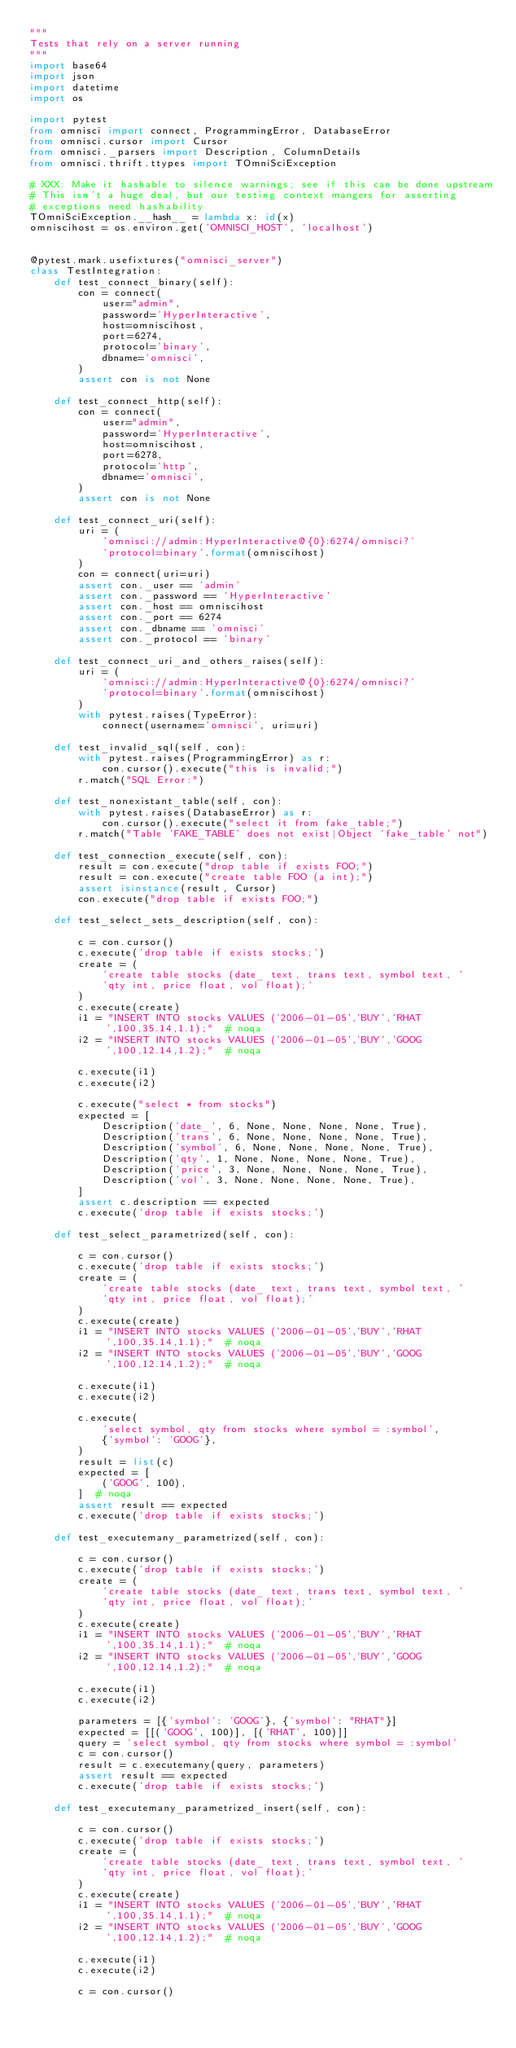Convert code to text. <code><loc_0><loc_0><loc_500><loc_500><_Python_>"""
Tests that rely on a server running
"""
import base64
import json
import datetime
import os

import pytest
from omnisci import connect, ProgrammingError, DatabaseError
from omnisci.cursor import Cursor
from omnisci._parsers import Description, ColumnDetails
from omnisci.thrift.ttypes import TOmniSciException

# XXX: Make it hashable to silence warnings; see if this can be done upstream
# This isn't a huge deal, but our testing context mangers for asserting
# exceptions need hashability
TOmniSciException.__hash__ = lambda x: id(x)
omniscihost = os.environ.get('OMNISCI_HOST', 'localhost')


@pytest.mark.usefixtures("omnisci_server")
class TestIntegration:
    def test_connect_binary(self):
        con = connect(
            user="admin",
            password='HyperInteractive',
            host=omniscihost,
            port=6274,
            protocol='binary',
            dbname='omnisci',
        )
        assert con is not None

    def test_connect_http(self):
        con = connect(
            user="admin",
            password='HyperInteractive',
            host=omniscihost,
            port=6278,
            protocol='http',
            dbname='omnisci',
        )
        assert con is not None

    def test_connect_uri(self):
        uri = (
            'omnisci://admin:HyperInteractive@{0}:6274/omnisci?'
            'protocol=binary'.format(omniscihost)
        )
        con = connect(uri=uri)
        assert con._user == 'admin'
        assert con._password == 'HyperInteractive'
        assert con._host == omniscihost
        assert con._port == 6274
        assert con._dbname == 'omnisci'
        assert con._protocol == 'binary'

    def test_connect_uri_and_others_raises(self):
        uri = (
            'omnisci://admin:HyperInteractive@{0}:6274/omnisci?'
            'protocol=binary'.format(omniscihost)
        )
        with pytest.raises(TypeError):
            connect(username='omnisci', uri=uri)

    def test_invalid_sql(self, con):
        with pytest.raises(ProgrammingError) as r:
            con.cursor().execute("this is invalid;")
        r.match("SQL Error:")

    def test_nonexistant_table(self, con):
        with pytest.raises(DatabaseError) as r:
            con.cursor().execute("select it from fake_table;")
        r.match("Table 'FAKE_TABLE' does not exist|Object 'fake_table' not")

    def test_connection_execute(self, con):
        result = con.execute("drop table if exists FOO;")
        result = con.execute("create table FOO (a int);")
        assert isinstance(result, Cursor)
        con.execute("drop table if exists FOO;")

    def test_select_sets_description(self, con):

        c = con.cursor()
        c.execute('drop table if exists stocks;')
        create = (
            'create table stocks (date_ text, trans text, symbol text, '
            'qty int, price float, vol float);'
        )
        c.execute(create)
        i1 = "INSERT INTO stocks VALUES ('2006-01-05','BUY','RHAT',100,35.14,1.1);"  # noqa
        i2 = "INSERT INTO stocks VALUES ('2006-01-05','BUY','GOOG',100,12.14,1.2);"  # noqa

        c.execute(i1)
        c.execute(i2)

        c.execute("select * from stocks")
        expected = [
            Description('date_', 6, None, None, None, None, True),
            Description('trans', 6, None, None, None, None, True),
            Description('symbol', 6, None, None, None, None, True),
            Description('qty', 1, None, None, None, None, True),
            Description('price', 3, None, None, None, None, True),
            Description('vol', 3, None, None, None, None, True),
        ]
        assert c.description == expected
        c.execute('drop table if exists stocks;')

    def test_select_parametrized(self, con):

        c = con.cursor()
        c.execute('drop table if exists stocks;')
        create = (
            'create table stocks (date_ text, trans text, symbol text, '
            'qty int, price float, vol float);'
        )
        c.execute(create)
        i1 = "INSERT INTO stocks VALUES ('2006-01-05','BUY','RHAT',100,35.14,1.1);"  # noqa
        i2 = "INSERT INTO stocks VALUES ('2006-01-05','BUY','GOOG',100,12.14,1.2);"  # noqa

        c.execute(i1)
        c.execute(i2)

        c.execute(
            'select symbol, qty from stocks where symbol = :symbol',
            {'symbol': 'GOOG'},
        )
        result = list(c)
        expected = [
            ('GOOG', 100),
        ]  # noqa
        assert result == expected
        c.execute('drop table if exists stocks;')

    def test_executemany_parametrized(self, con):

        c = con.cursor()
        c.execute('drop table if exists stocks;')
        create = (
            'create table stocks (date_ text, trans text, symbol text, '
            'qty int, price float, vol float);'
        )
        c.execute(create)
        i1 = "INSERT INTO stocks VALUES ('2006-01-05','BUY','RHAT',100,35.14,1.1);"  # noqa
        i2 = "INSERT INTO stocks VALUES ('2006-01-05','BUY','GOOG',100,12.14,1.2);"  # noqa

        c.execute(i1)
        c.execute(i2)

        parameters = [{'symbol': 'GOOG'}, {'symbol': "RHAT"}]
        expected = [[('GOOG', 100)], [('RHAT', 100)]]
        query = 'select symbol, qty from stocks where symbol = :symbol'
        c = con.cursor()
        result = c.executemany(query, parameters)
        assert result == expected
        c.execute('drop table if exists stocks;')

    def test_executemany_parametrized_insert(self, con):

        c = con.cursor()
        c.execute('drop table if exists stocks;')
        create = (
            'create table stocks (date_ text, trans text, symbol text, '
            'qty int, price float, vol float);'
        )
        c.execute(create)
        i1 = "INSERT INTO stocks VALUES ('2006-01-05','BUY','RHAT',100,35.14,1.1);"  # noqa
        i2 = "INSERT INTO stocks VALUES ('2006-01-05','BUY','GOOG',100,12.14,1.2);"  # noqa

        c.execute(i1)
        c.execute(i2)

        c = con.cursor()</code> 